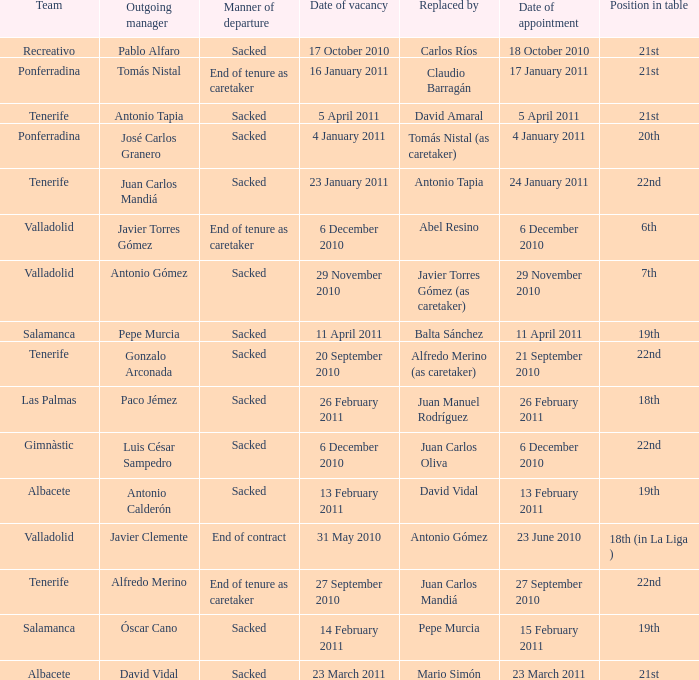What is the position for outgoing manager alfredo merino 22nd. 